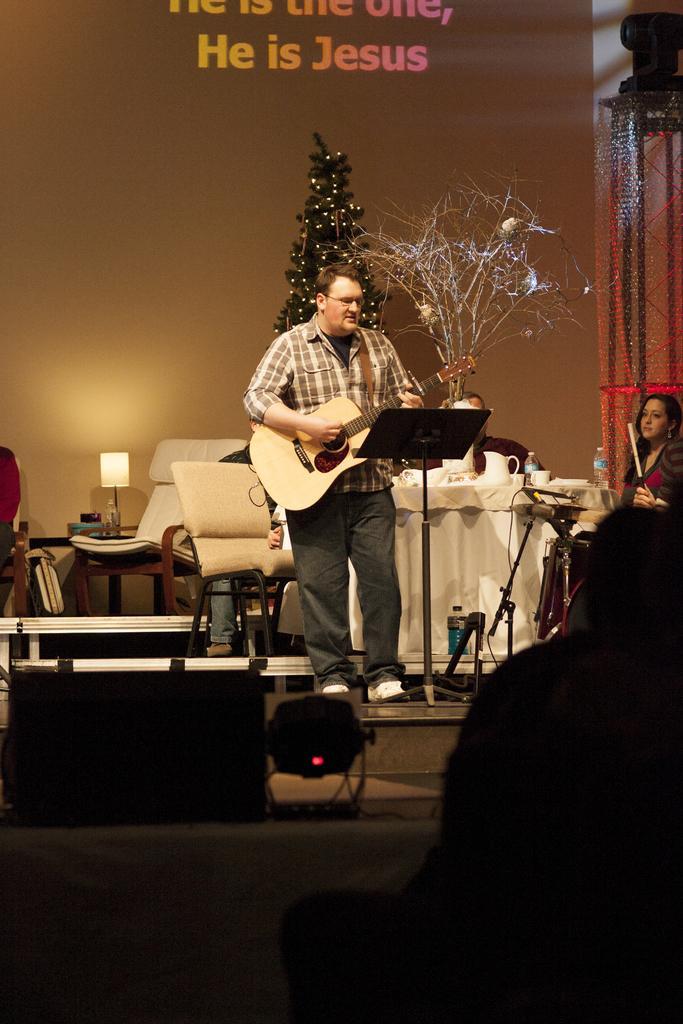How would you summarize this image in a sentence or two? As we can see in the image, there are two persons. The person who is standing here is holding guitar in his hand and singing a song on mike. Behind him there is a chair and a table. On table there is a plant and mug. Behind them there is a banner. 